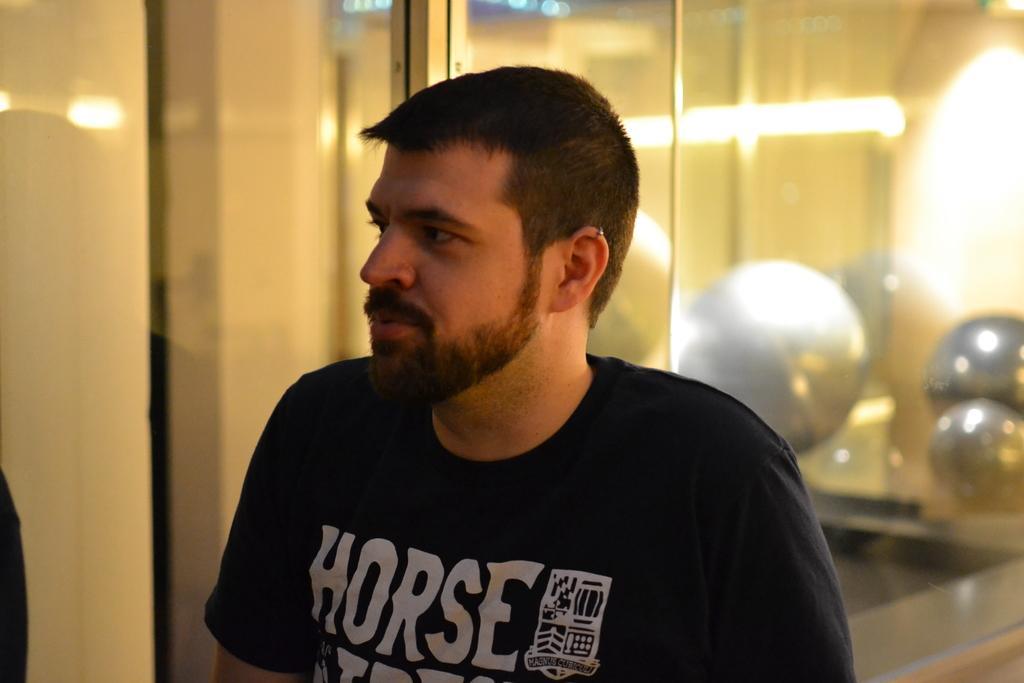Describe this image in one or two sentences. There is a man wearing t shirt. In the back there is a wall. Also there are lights. 